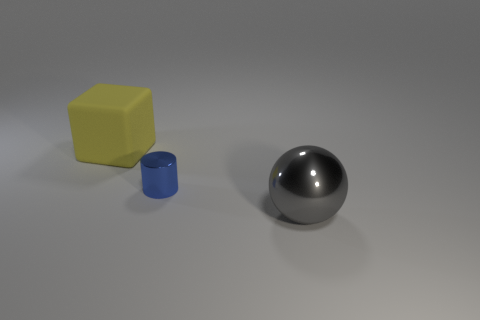Add 2 tiny things. How many objects exist? 5 Subtract all cubes. How many objects are left? 2 Subtract all big gray things. Subtract all big cyan rubber objects. How many objects are left? 2 Add 1 small blue cylinders. How many small blue cylinders are left? 2 Add 1 shiny objects. How many shiny objects exist? 3 Subtract 0 purple blocks. How many objects are left? 3 